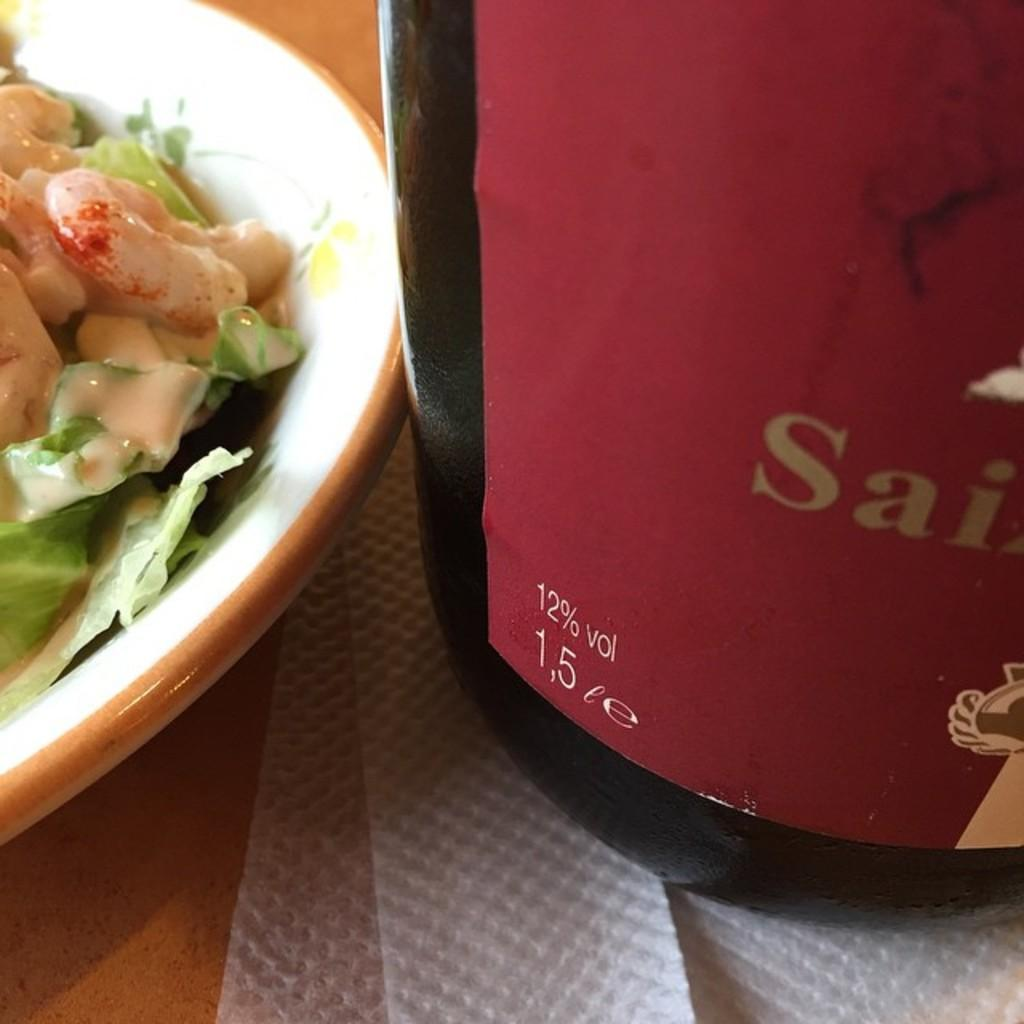What is the food item served in the image? There is a food item served in a bowl in the image, but the specific type of food is not mentioned. What is located beside the bowl in the image? There is a bottle beside the bowl in the image. What can be used for cleaning or wiping in the image? Tissues are present in the image for cleaning or wiping. What type of vegetable can be seen growing in the image? There is no vegetable growing in the image; it only shows a food item served in a bowl, a bottle, and tissues. How does the grip of the bottle in the image compare to other bottles? The grip of the bottle in the image cannot be compared to other bottles, as there is no reference to other bottles in the image. 